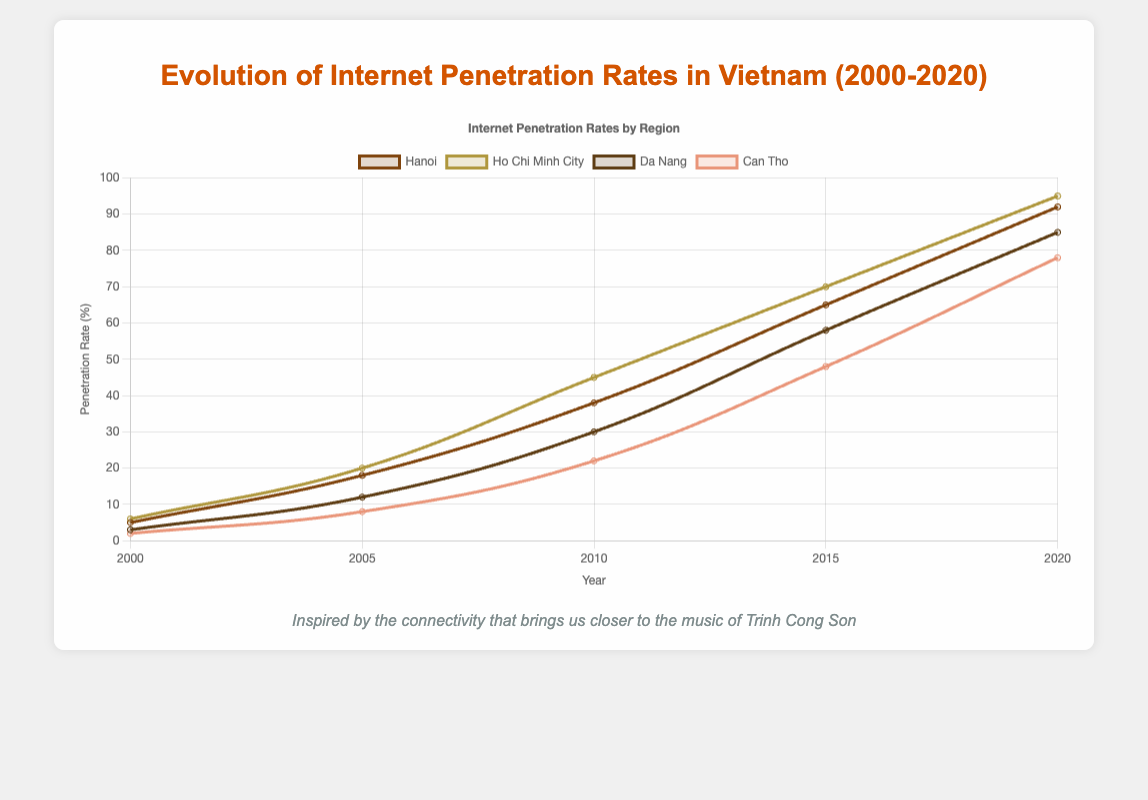What was the internet penetration rate in Hanoi in 2000? Looking at Hanoi's penetration rate in 2000 from the figure, it's depicted at the beginning of the line series for Hanoi, which is its lowest point on the left side of the graph.
Answer: 5% Which region had the highest internet penetration rate in 2020? Ho Chi Minh City's rate in 2020 is the highest among all regions as seen from the endpoints of the lines on the right side of the graph.
Answer: Ho Chi Minh City How did the internet penetration rate in Da Nang in 2020 compare with that in 2010? Find Da Nang's values at the 2010 and 2020 points on the graph. The penetration rate in 2020 is much higher than in 2010.
Answer: Increased Calculate the average internet penetration rate of Can Tho in 2000, 2005, and 2010. Sum the rates in 2000 (2%), 2005 (8%), and 2010 (22%) and divide by 3. (2 + 8 + 22) / 3 = 32 / 3
Answer: 10.67% What is the difference in internet penetration rates between Hanoi and Can Tho in 2020? Look at the endpoints on the right side of the graph for both Hanoi and Can Tho. Subtract Can Tho’s rate from Hanoi’s rate (92% - 78%).
Answer: 14% Which region showed the smallest increase in internet penetration rate from 2000 to 2005? Comparing the steepness of the lines from 2000 to 2005 for all regions, Can Tho shows the smallest increase.
Answer: Can Tho Is the internet penetration rate of Ho Chi Minh City in 2015 greater than or equal to Da Nang’s in 2020? Check the 2015 point for Ho Chi Minh City and 2020 point for Da Nang and compare. Ho Chi Minh City's rate in 2015 (70%) is less than Da Nang's rate in 2020 (85%).
Answer: No What is the median internet penetration rate of Da Nang over the years 2005, 2010, and 2015? Sort the rates of Da Nang for these years: [12%, 30%, 58%]. The median is the middle value, which is 30%.
Answer: 30% Which periods saw the largest increase for Hanoi? From visual inspection, check the slope of Hanoi’s lines. Between 2005 and 2010, the slope is the steepest indicating the largest increase.
Answer: 2005-2010 